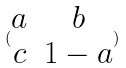<formula> <loc_0><loc_0><loc_500><loc_500>( \begin{matrix} a & b \\ c & 1 - a \end{matrix} )</formula> 